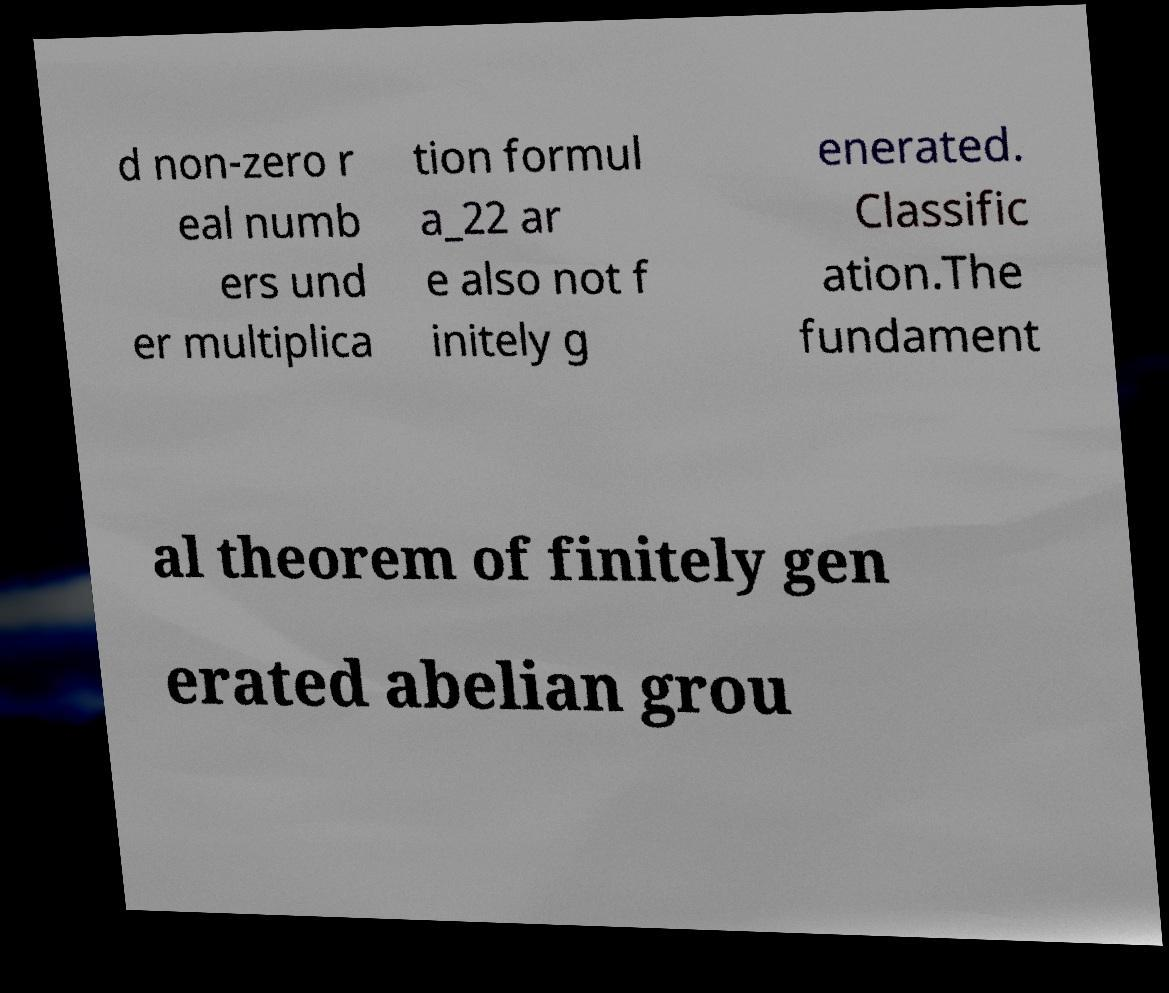Please identify and transcribe the text found in this image. d non-zero r eal numb ers und er multiplica tion formul a_22 ar e also not f initely g enerated. Classific ation.The fundament al theorem of finitely gen erated abelian grou 